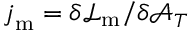<formula> <loc_0><loc_0><loc_500><loc_500>j _ { m } = \delta \mathcal { L } _ { m } / \delta \mathcal { A } _ { T }</formula> 